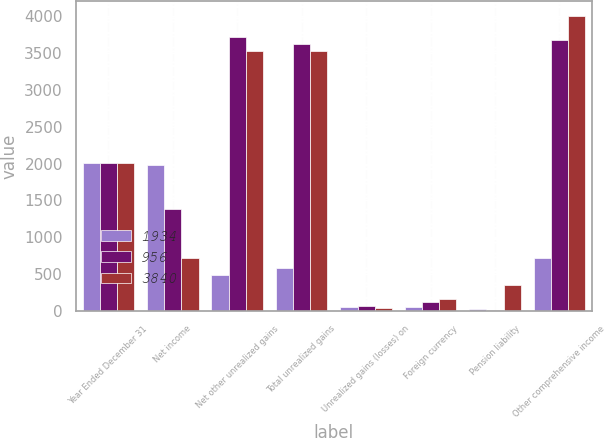<chart> <loc_0><loc_0><loc_500><loc_500><stacked_bar_chart><ecel><fcel>Year Ended December 31<fcel>Net income<fcel>Net other unrealized gains<fcel>Total unrealized gains<fcel>Unrealized gains (losses) on<fcel>Foreign currency<fcel>Pension liability<fcel>Other comprehensive income<nl><fcel>1934<fcel>2010<fcel>1987<fcel>494<fcel>580<fcel>60<fcel>49<fcel>29<fcel>718<nl><fcel>956<fcel>2009<fcel>1383<fcel>3711<fcel>3616<fcel>67<fcel>117<fcel>6<fcel>3672<nl><fcel>3840<fcel>2008<fcel>718<fcel>3528<fcel>3528<fcel>41<fcel>161<fcel>354<fcel>4002<nl></chart> 